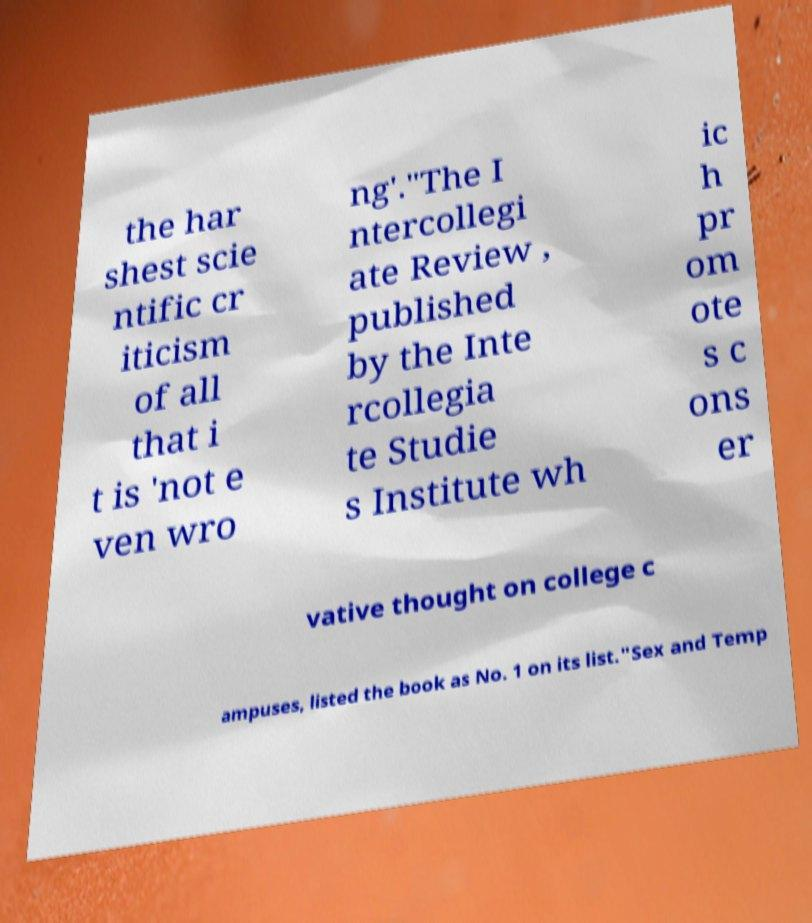Can you read and provide the text displayed in the image?This photo seems to have some interesting text. Can you extract and type it out for me? the har shest scie ntific cr iticism of all that i t is 'not e ven wro ng'."The I ntercollegi ate Review , published by the Inte rcollegia te Studie s Institute wh ic h pr om ote s c ons er vative thought on college c ampuses, listed the book as No. 1 on its list."Sex and Temp 